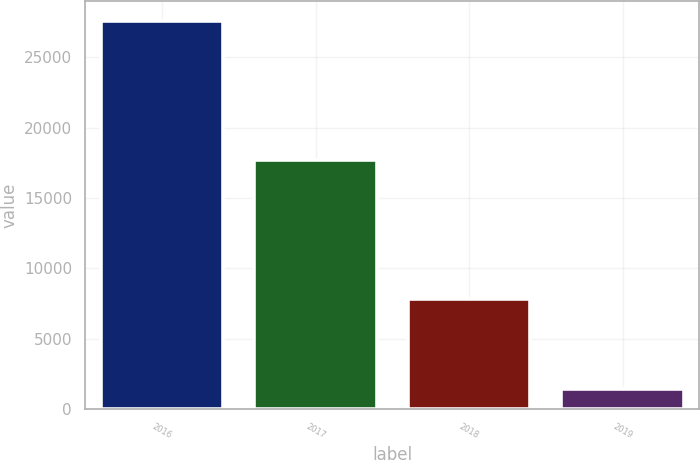Convert chart to OTSL. <chart><loc_0><loc_0><loc_500><loc_500><bar_chart><fcel>2016<fcel>2017<fcel>2018<fcel>2019<nl><fcel>27599<fcel>17713<fcel>7827<fcel>1442<nl></chart> 